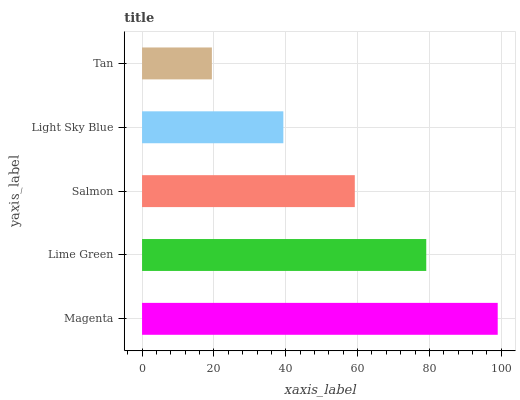Is Tan the minimum?
Answer yes or no. Yes. Is Magenta the maximum?
Answer yes or no. Yes. Is Lime Green the minimum?
Answer yes or no. No. Is Lime Green the maximum?
Answer yes or no. No. Is Magenta greater than Lime Green?
Answer yes or no. Yes. Is Lime Green less than Magenta?
Answer yes or no. Yes. Is Lime Green greater than Magenta?
Answer yes or no. No. Is Magenta less than Lime Green?
Answer yes or no. No. Is Salmon the high median?
Answer yes or no. Yes. Is Salmon the low median?
Answer yes or no. Yes. Is Lime Green the high median?
Answer yes or no. No. Is Tan the low median?
Answer yes or no. No. 